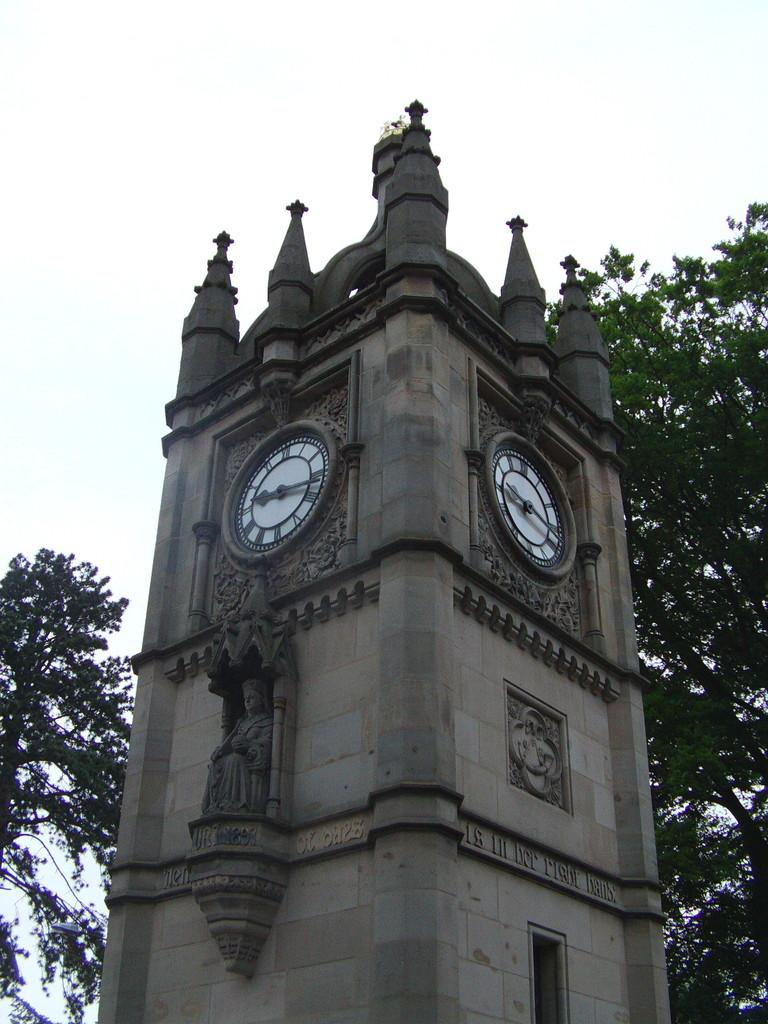What is the main structure in the image? There is a tower in the image. What is attached to the tower? A clock is attached to the tower. What can be seen in the sky in the image? The sky is visible in the image. What type of vegetation is present in the image? There is a tree in the image. How many fangs can be seen on the tree in the image? There are no fangs present on the tree in the image; it is a regular tree. What type of art is displayed on the tower in the image? There is no art displayed on the tower in the image; it only has a clock attached. 